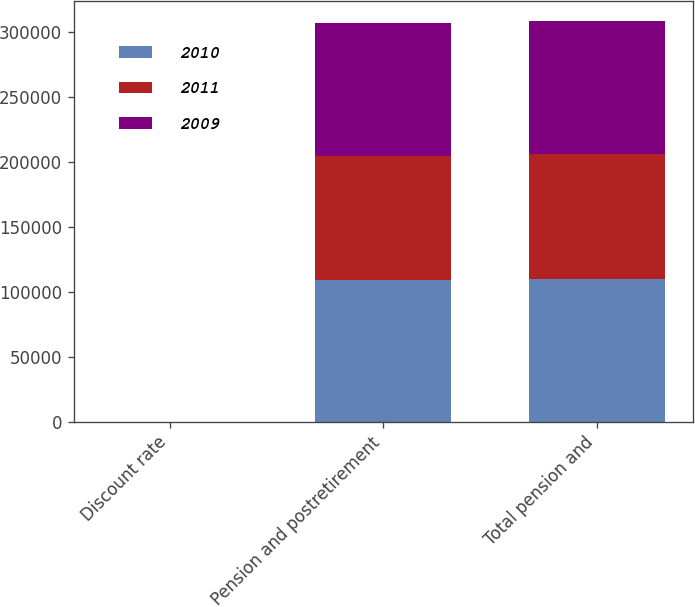Convert chart. <chart><loc_0><loc_0><loc_500><loc_500><stacked_bar_chart><ecel><fcel>Discount rate<fcel>Pension and postretirement<fcel>Total pension and<nl><fcel>2010<fcel>5.49<fcel>109161<fcel>109825<nl><fcel>2011<fcel>5.74<fcel>95528<fcel>96047<nl><fcel>2009<fcel>6<fcel>102046<fcel>102527<nl></chart> 